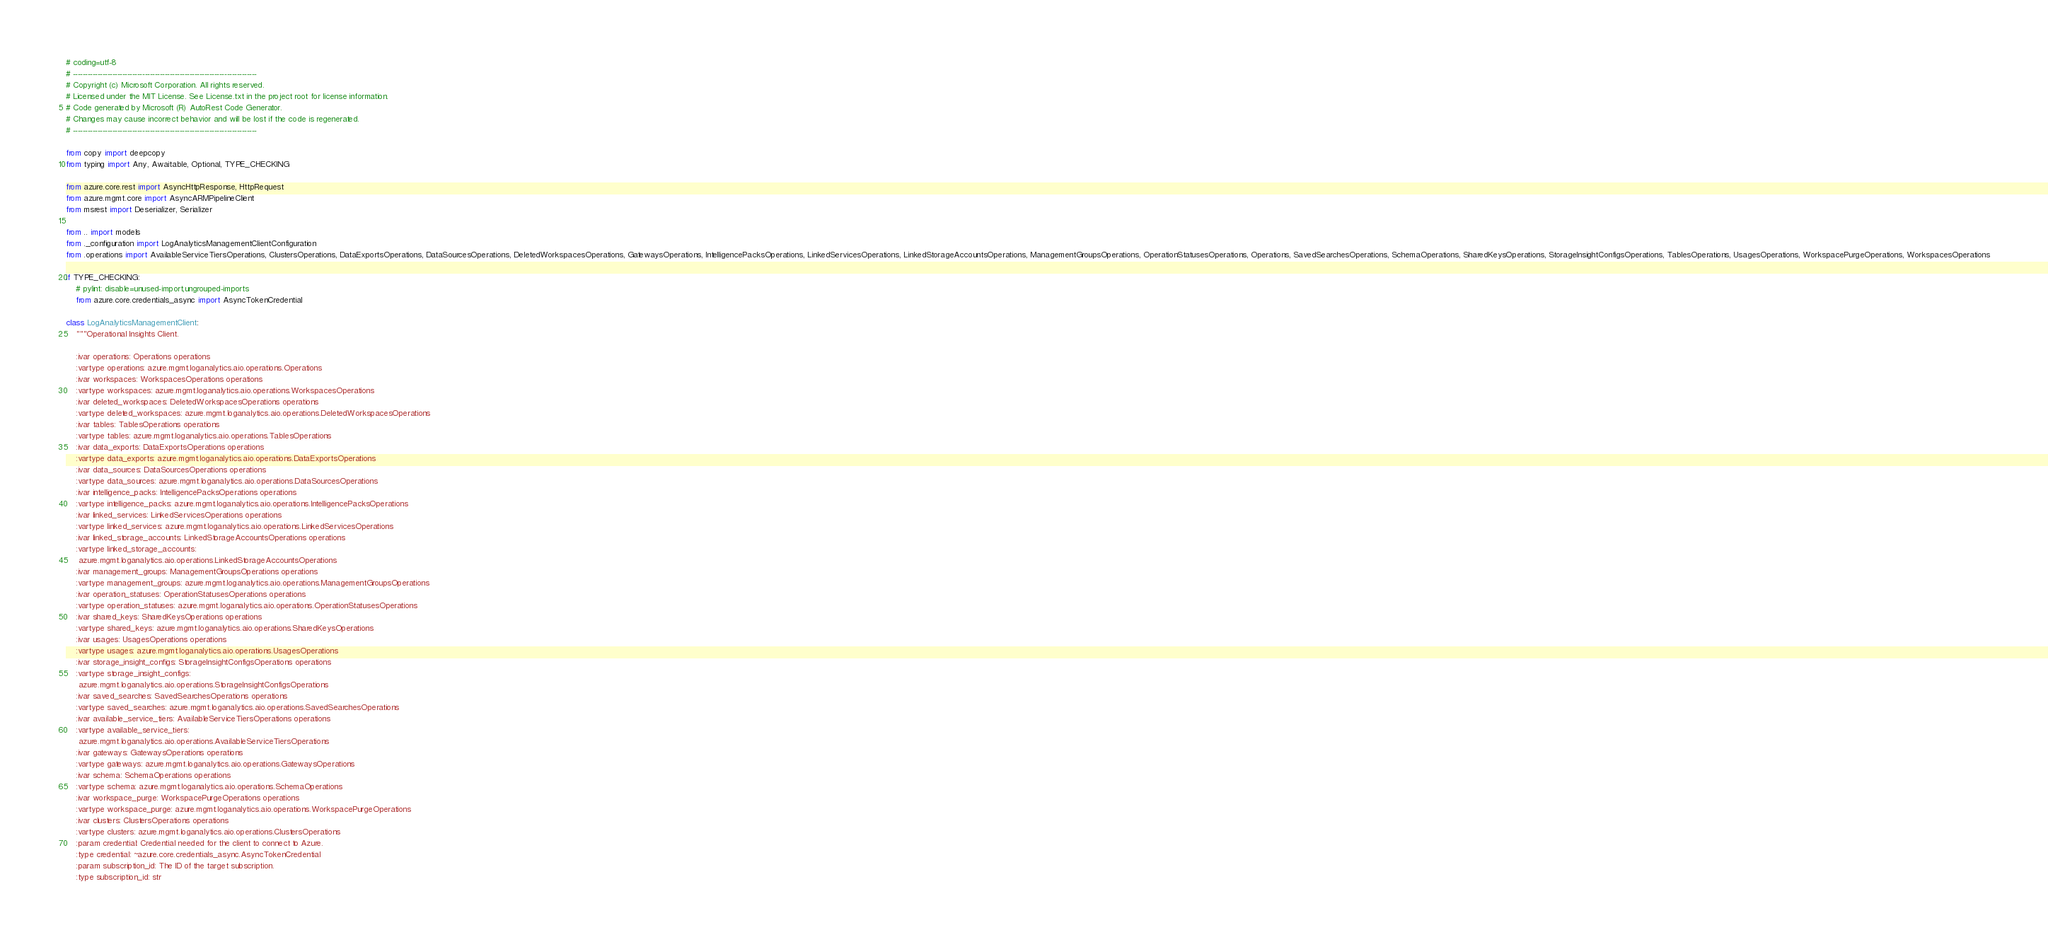<code> <loc_0><loc_0><loc_500><loc_500><_Python_># coding=utf-8
# --------------------------------------------------------------------------
# Copyright (c) Microsoft Corporation. All rights reserved.
# Licensed under the MIT License. See License.txt in the project root for license information.
# Code generated by Microsoft (R) AutoRest Code Generator.
# Changes may cause incorrect behavior and will be lost if the code is regenerated.
# --------------------------------------------------------------------------

from copy import deepcopy
from typing import Any, Awaitable, Optional, TYPE_CHECKING

from azure.core.rest import AsyncHttpResponse, HttpRequest
from azure.mgmt.core import AsyncARMPipelineClient
from msrest import Deserializer, Serializer

from .. import models
from ._configuration import LogAnalyticsManagementClientConfiguration
from .operations import AvailableServiceTiersOperations, ClustersOperations, DataExportsOperations, DataSourcesOperations, DeletedWorkspacesOperations, GatewaysOperations, IntelligencePacksOperations, LinkedServicesOperations, LinkedStorageAccountsOperations, ManagementGroupsOperations, OperationStatusesOperations, Operations, SavedSearchesOperations, SchemaOperations, SharedKeysOperations, StorageInsightConfigsOperations, TablesOperations, UsagesOperations, WorkspacePurgeOperations, WorkspacesOperations

if TYPE_CHECKING:
    # pylint: disable=unused-import,ungrouped-imports
    from azure.core.credentials_async import AsyncTokenCredential

class LogAnalyticsManagementClient:
    """Operational Insights Client.

    :ivar operations: Operations operations
    :vartype operations: azure.mgmt.loganalytics.aio.operations.Operations
    :ivar workspaces: WorkspacesOperations operations
    :vartype workspaces: azure.mgmt.loganalytics.aio.operations.WorkspacesOperations
    :ivar deleted_workspaces: DeletedWorkspacesOperations operations
    :vartype deleted_workspaces: azure.mgmt.loganalytics.aio.operations.DeletedWorkspacesOperations
    :ivar tables: TablesOperations operations
    :vartype tables: azure.mgmt.loganalytics.aio.operations.TablesOperations
    :ivar data_exports: DataExportsOperations operations
    :vartype data_exports: azure.mgmt.loganalytics.aio.operations.DataExportsOperations
    :ivar data_sources: DataSourcesOperations operations
    :vartype data_sources: azure.mgmt.loganalytics.aio.operations.DataSourcesOperations
    :ivar intelligence_packs: IntelligencePacksOperations operations
    :vartype intelligence_packs: azure.mgmt.loganalytics.aio.operations.IntelligencePacksOperations
    :ivar linked_services: LinkedServicesOperations operations
    :vartype linked_services: azure.mgmt.loganalytics.aio.operations.LinkedServicesOperations
    :ivar linked_storage_accounts: LinkedStorageAccountsOperations operations
    :vartype linked_storage_accounts:
     azure.mgmt.loganalytics.aio.operations.LinkedStorageAccountsOperations
    :ivar management_groups: ManagementGroupsOperations operations
    :vartype management_groups: azure.mgmt.loganalytics.aio.operations.ManagementGroupsOperations
    :ivar operation_statuses: OperationStatusesOperations operations
    :vartype operation_statuses: azure.mgmt.loganalytics.aio.operations.OperationStatusesOperations
    :ivar shared_keys: SharedKeysOperations operations
    :vartype shared_keys: azure.mgmt.loganalytics.aio.operations.SharedKeysOperations
    :ivar usages: UsagesOperations operations
    :vartype usages: azure.mgmt.loganalytics.aio.operations.UsagesOperations
    :ivar storage_insight_configs: StorageInsightConfigsOperations operations
    :vartype storage_insight_configs:
     azure.mgmt.loganalytics.aio.operations.StorageInsightConfigsOperations
    :ivar saved_searches: SavedSearchesOperations operations
    :vartype saved_searches: azure.mgmt.loganalytics.aio.operations.SavedSearchesOperations
    :ivar available_service_tiers: AvailableServiceTiersOperations operations
    :vartype available_service_tiers:
     azure.mgmt.loganalytics.aio.operations.AvailableServiceTiersOperations
    :ivar gateways: GatewaysOperations operations
    :vartype gateways: azure.mgmt.loganalytics.aio.operations.GatewaysOperations
    :ivar schema: SchemaOperations operations
    :vartype schema: azure.mgmt.loganalytics.aio.operations.SchemaOperations
    :ivar workspace_purge: WorkspacePurgeOperations operations
    :vartype workspace_purge: azure.mgmt.loganalytics.aio.operations.WorkspacePurgeOperations
    :ivar clusters: ClustersOperations operations
    :vartype clusters: azure.mgmt.loganalytics.aio.operations.ClustersOperations
    :param credential: Credential needed for the client to connect to Azure.
    :type credential: ~azure.core.credentials_async.AsyncTokenCredential
    :param subscription_id: The ID of the target subscription.
    :type subscription_id: str</code> 